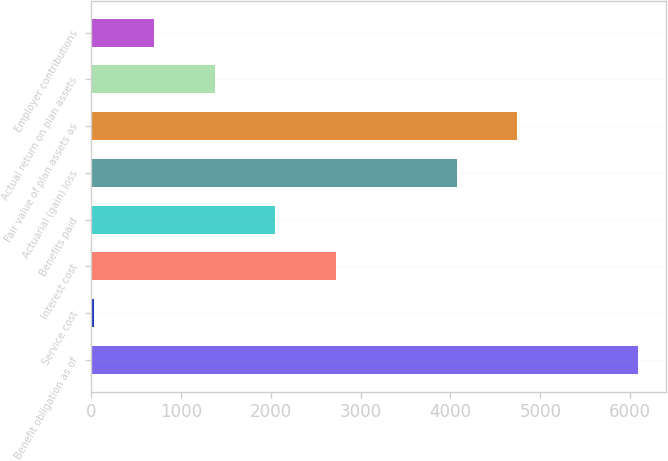Convert chart. <chart><loc_0><loc_0><loc_500><loc_500><bar_chart><fcel>Benefit obligation as of<fcel>Service cost<fcel>Interest cost<fcel>Benefits paid<fcel>Actuarial (gain) loss<fcel>Fair value of plan assets as<fcel>Actual return on plan assets<fcel>Employer contributions<nl><fcel>6093.8<fcel>26<fcel>2722.8<fcel>2048.6<fcel>4071.2<fcel>4745.4<fcel>1374.4<fcel>700.2<nl></chart> 